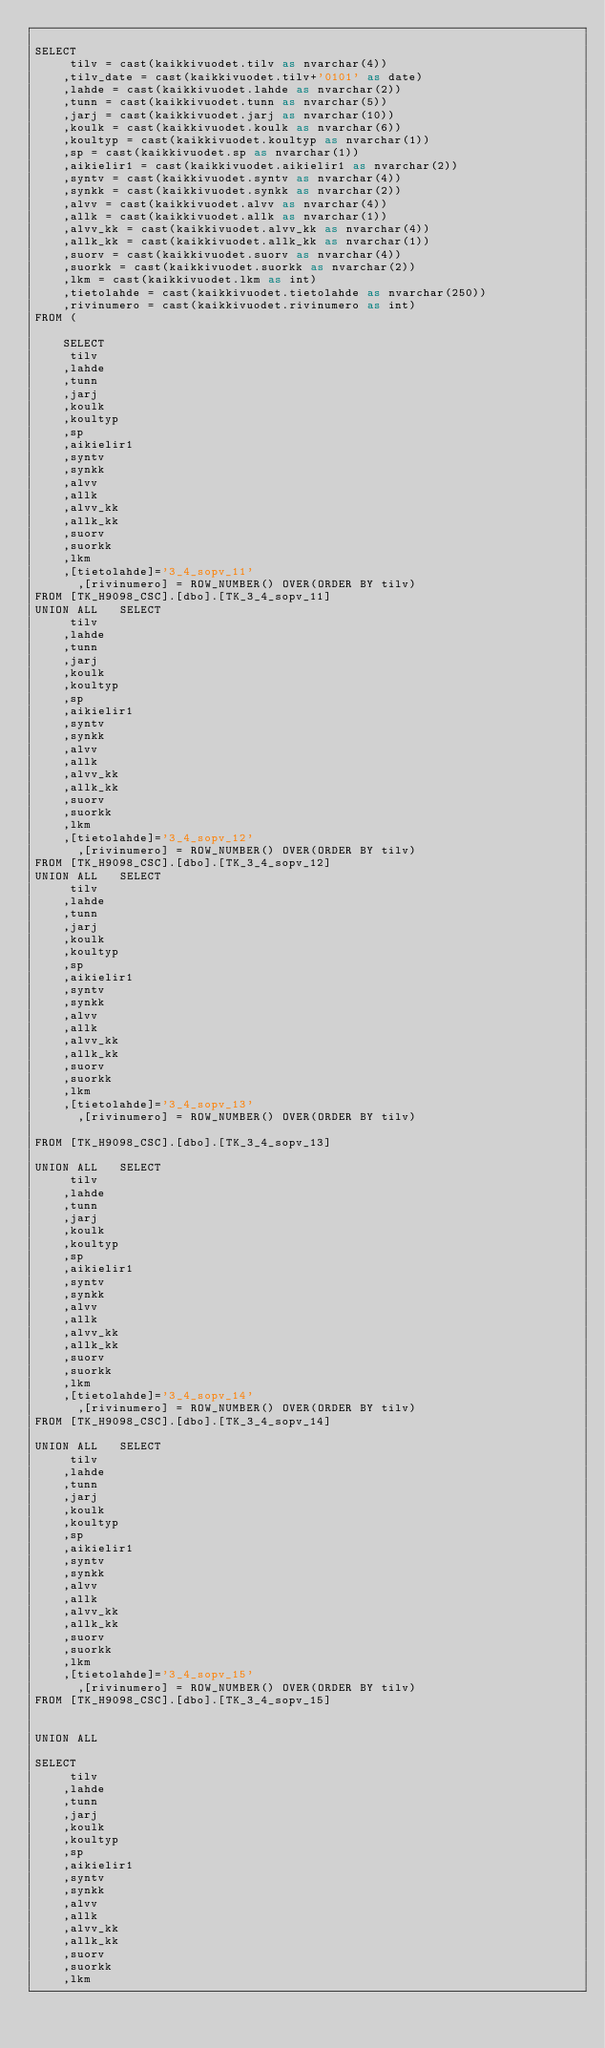<code> <loc_0><loc_0><loc_500><loc_500><_SQL_>
SELECT
	 tilv = cast(kaikkivuodet.tilv as nvarchar(4))
	,tilv_date = cast(kaikkivuodet.tilv+'0101' as date)
	,lahde = cast(kaikkivuodet.lahde as nvarchar(2))
	,tunn = cast(kaikkivuodet.tunn as nvarchar(5))
	,jarj = cast(kaikkivuodet.jarj as nvarchar(10))
	,koulk = cast(kaikkivuodet.koulk as nvarchar(6))
	,koultyp = cast(kaikkivuodet.koultyp as nvarchar(1))
	,sp = cast(kaikkivuodet.sp as nvarchar(1))
	,aikielir1 = cast(kaikkivuodet.aikielir1 as nvarchar(2))
	,syntv = cast(kaikkivuodet.syntv as nvarchar(4))
	,synkk = cast(kaikkivuodet.synkk as nvarchar(2))
	,alvv = cast(kaikkivuodet.alvv as nvarchar(4))
	,allk = cast(kaikkivuodet.allk as nvarchar(1))
	,alvv_kk = cast(kaikkivuodet.alvv_kk as nvarchar(4))
	,allk_kk = cast(kaikkivuodet.allk_kk as nvarchar(1))
	,suorv = cast(kaikkivuodet.suorv as nvarchar(4))
	,suorkk = cast(kaikkivuodet.suorkk as nvarchar(2))
	,lkm = cast(kaikkivuodet.lkm as int)
	,tietolahde = cast(kaikkivuodet.tietolahde as nvarchar(250))
	,rivinumero = cast(kaikkivuodet.rivinumero as int)
FROM (

	SELECT
	 tilv
	,lahde
	,tunn
	,jarj
	,koulk
	,koultyp
	,sp
	,aikielir1
	,syntv
	,synkk
	,alvv
	,allk
	,alvv_kk
	,allk_kk
	,suorv
	,suorkk
	,lkm
	,[tietolahde]='3_4_sopv_11'
      ,[rivinumero] = ROW_NUMBER() OVER(ORDER BY tilv)
FROM [TK_H9098_CSC].[dbo].[TK_3_4_sopv_11]
UNION ALL 	SELECT
	 tilv
	,lahde
	,tunn
	,jarj
	,koulk
	,koultyp
	,sp
	,aikielir1
	,syntv
	,synkk
	,alvv
	,allk
	,alvv_kk
	,allk_kk
	,suorv
	,suorkk
	,lkm
	,[tietolahde]='3_4_sopv_12'
      ,[rivinumero] = ROW_NUMBER() OVER(ORDER BY tilv)
FROM [TK_H9098_CSC].[dbo].[TK_3_4_sopv_12]
UNION ALL 	SELECT
	 tilv
	,lahde
	,tunn
	,jarj
	,koulk
	,koultyp
	,sp
	,aikielir1
	,syntv
	,synkk
	,alvv
	,allk
	,alvv_kk
	,allk_kk
	,suorv
	,suorkk
	,lkm
	,[tietolahde]='3_4_sopv_13'
      ,[rivinumero] = ROW_NUMBER() OVER(ORDER BY tilv)

FROM [TK_H9098_CSC].[dbo].[TK_3_4_sopv_13]

UNION ALL 	SELECT
	 tilv
	,lahde
	,tunn
	,jarj
	,koulk
	,koultyp
	,sp
	,aikielir1
	,syntv
	,synkk
	,alvv
	,allk
	,alvv_kk
	,allk_kk
	,suorv
	,suorkk
	,lkm
	,[tietolahde]='3_4_sopv_14'
      ,[rivinumero] = ROW_NUMBER() OVER(ORDER BY tilv)
FROM [TK_H9098_CSC].[dbo].[TK_3_4_sopv_14]

UNION ALL 	SELECT
	 tilv
	,lahde
	,tunn
	,jarj
	,koulk
	,koultyp
	,sp
	,aikielir1
	,syntv
	,synkk
	,alvv
	,allk
	,alvv_kk
	,allk_kk
	,suorv
	,suorkk
	,lkm
	,[tietolahde]='3_4_sopv_15'
      ,[rivinumero] = ROW_NUMBER() OVER(ORDER BY tilv)
FROM [TK_H9098_CSC].[dbo].[TK_3_4_sopv_15]


UNION ALL 	

SELECT
	 tilv
	,lahde
	,tunn
	,jarj
	,koulk
	,koultyp
	,sp
	,aikielir1
	,syntv
	,synkk
	,alvv
	,allk
	,alvv_kk
	,allk_kk
	,suorv
	,suorkk
	,lkm</code> 